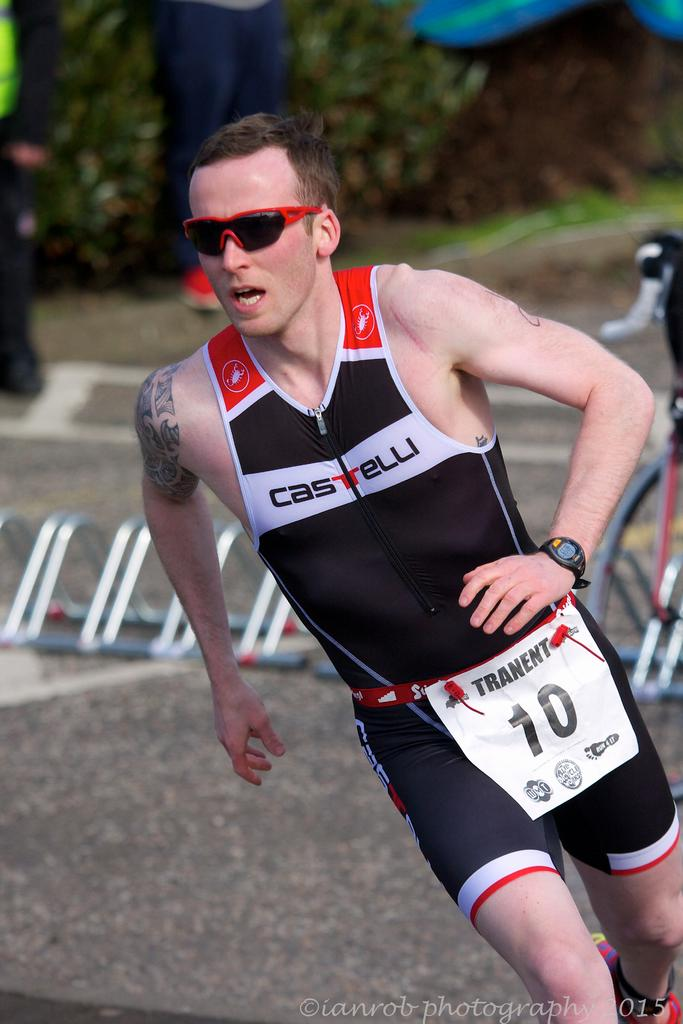<image>
Offer a succinct explanation of the picture presented. A runner competing wearing bib number 10 is wearing red shades and a black, white and red one piece. 